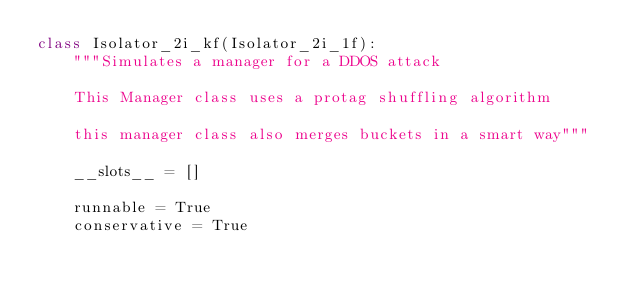Convert code to text. <code><loc_0><loc_0><loc_500><loc_500><_Python_>class Isolator_2i_kf(Isolator_2i_1f):
    """Simulates a manager for a DDOS attack

    This Manager class uses a protag shuffling algorithm

    this manager class also merges buckets in a smart way"""

    __slots__ = []

    runnable = True
    conservative = True
</code> 